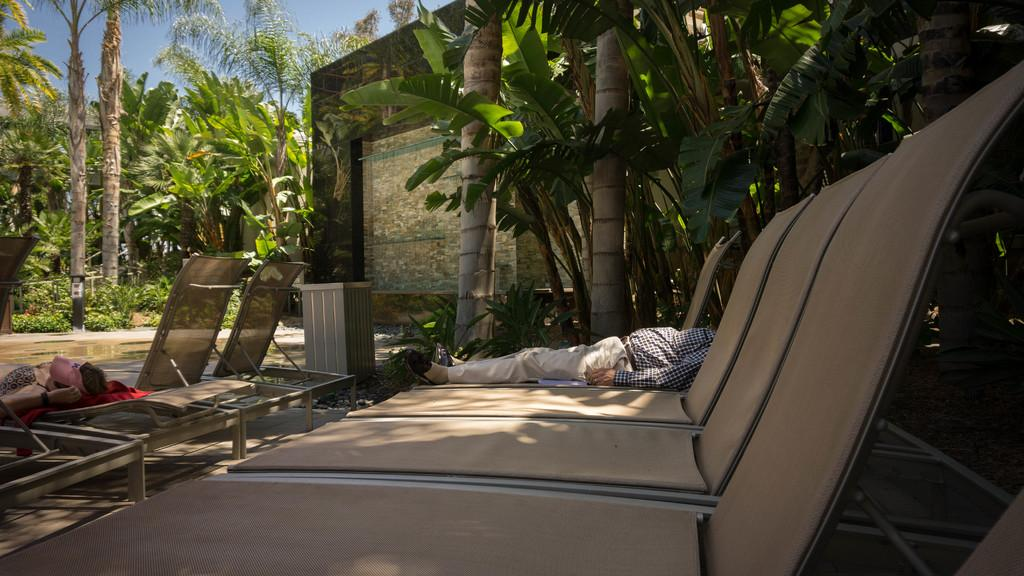What type of seating is visible in the image? There are benches in the image. What are the people on the benches doing? People are sleeping on the benches. What structures can be seen in the background of the image? There are buildings in the image. What type of vegetation is present in the image? There are trees in the image. How many balls are being juggled by the people sleeping on the benches? There are no balls present in the image; people are sleeping on the benches. What type of fruit is being eaten by the trees in the image? Trees do not eat fruit; they are a type of vegetation present in the image. 